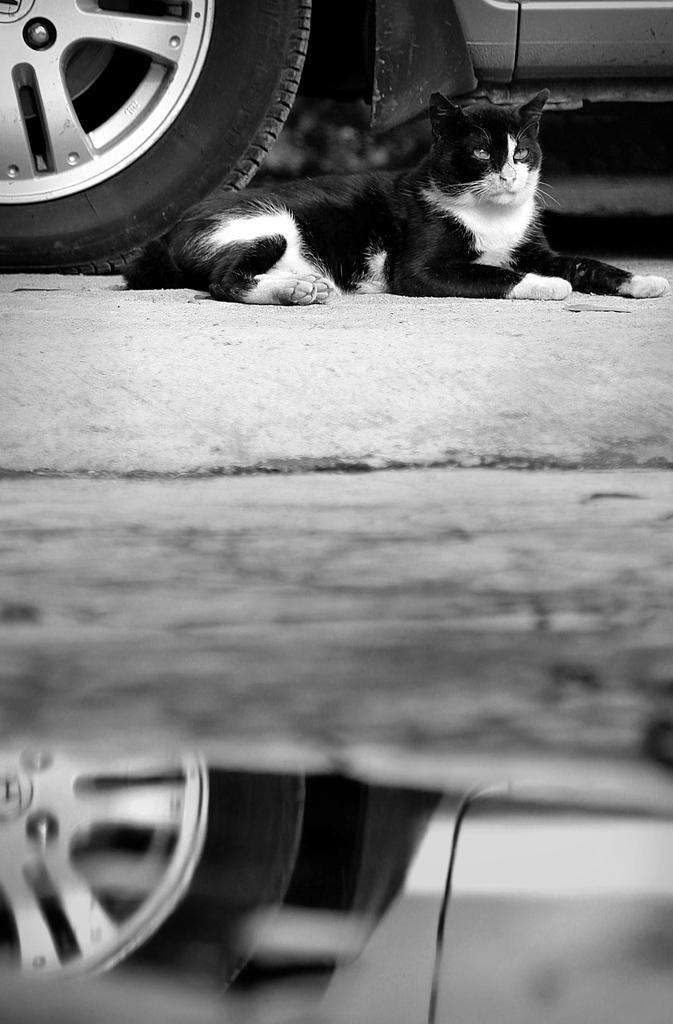How would you summarize this image in a sentence or two? In this picture we can see a cat is laying on the ground beside to the wheel. 